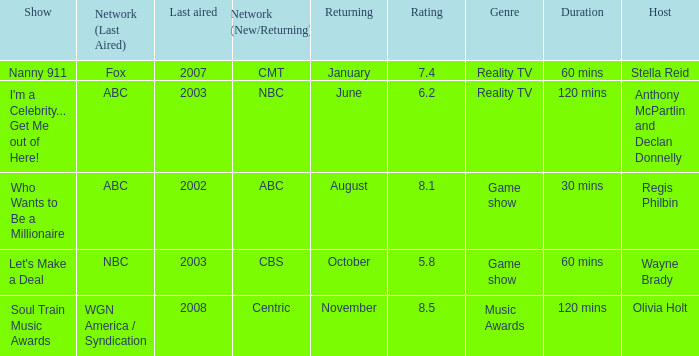What show was played on ABC laster after 2002? I'm a Celebrity... Get Me out of Here!. 